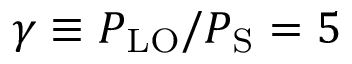<formula> <loc_0><loc_0><loc_500><loc_500>\gamma \equiv P _ { L O } / P _ { S } = 5</formula> 